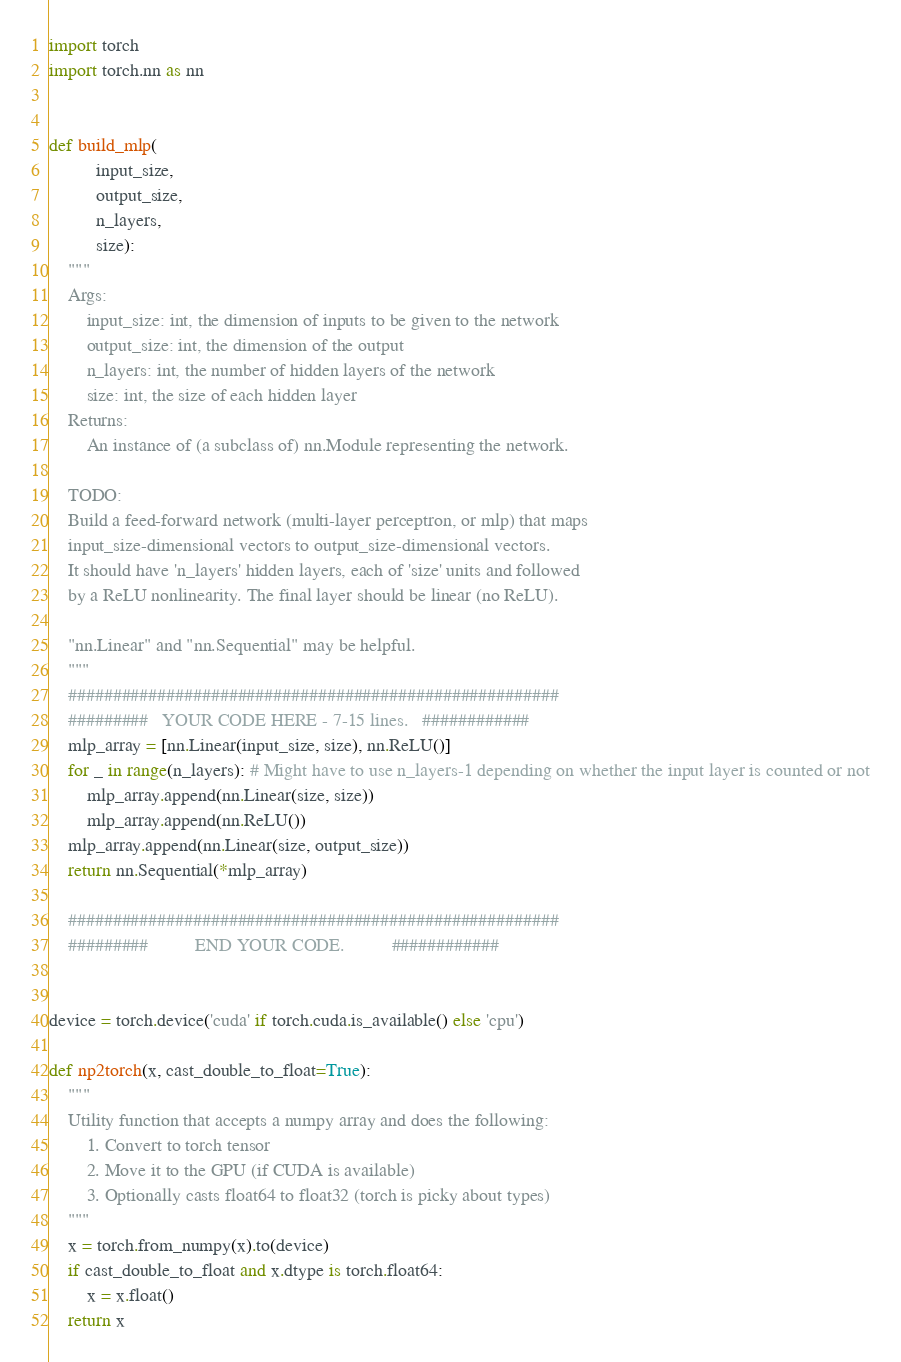Convert code to text. <code><loc_0><loc_0><loc_500><loc_500><_Python_>import torch
import torch.nn as nn


def build_mlp(
          input_size,
          output_size,
          n_layers,
          size):
    """
    Args:
        input_size: int, the dimension of inputs to be given to the network
        output_size: int, the dimension of the output
        n_layers: int, the number of hidden layers of the network
        size: int, the size of each hidden layer
    Returns:
        An instance of (a subclass of) nn.Module representing the network.

    TODO:
    Build a feed-forward network (multi-layer perceptron, or mlp) that maps
    input_size-dimensional vectors to output_size-dimensional vectors.
    It should have 'n_layers' hidden layers, each of 'size' units and followed
    by a ReLU nonlinearity. The final layer should be linear (no ReLU).

    "nn.Linear" and "nn.Sequential" may be helpful.
    """
    #######################################################
    #########   YOUR CODE HERE - 7-15 lines.   ############
    mlp_array = [nn.Linear(input_size, size), nn.ReLU()]
    for _ in range(n_layers): # Might have to use n_layers-1 depending on whether the input layer is counted or not
        mlp_array.append(nn.Linear(size, size))
        mlp_array.append(nn.ReLU())
    mlp_array.append(nn.Linear(size, output_size))
    return nn.Sequential(*mlp_array)

    #######################################################
    #########          END YOUR CODE.          ############


device = torch.device('cuda' if torch.cuda.is_available() else 'cpu')

def np2torch(x, cast_double_to_float=True):
    """
    Utility function that accepts a numpy array and does the following:
        1. Convert to torch tensor
        2. Move it to the GPU (if CUDA is available)
        3. Optionally casts float64 to float32 (torch is picky about types)
    """
    x = torch.from_numpy(x).to(device)
    if cast_double_to_float and x.dtype is torch.float64:
        x = x.float()
    return x
</code> 